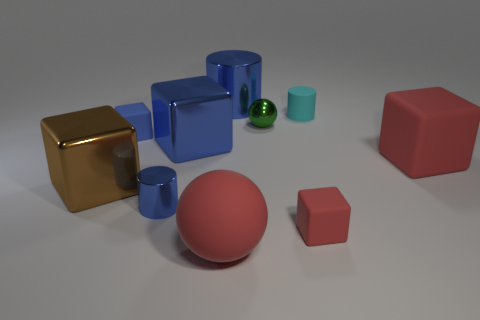There is a red rubber block that is behind the brown shiny object; is its size the same as the big brown metal block?
Give a very brief answer. Yes. What is the large blue object that is in front of the tiny green metal object made of?
Your answer should be compact. Metal. How many matte things are blocks or yellow spheres?
Give a very brief answer. 3. Are there fewer matte cylinders left of the large blue metal block than tiny blue rubber cubes?
Your response must be concise. Yes. The large red thing that is behind the cylinder in front of the cube that is right of the cyan matte cylinder is what shape?
Offer a terse response. Cube. Do the tiny metallic cylinder and the large cylinder have the same color?
Your answer should be compact. Yes. Are there more shiny objects than large brown balls?
Ensure brevity in your answer.  Yes. What number of other things are the same material as the red ball?
Your answer should be compact. 4. How many things are either big shiny blocks or blue matte cubes to the left of the tiny cyan matte cylinder?
Offer a very short reply. 3. Are there fewer big cylinders than tiny green matte balls?
Your response must be concise. No. 